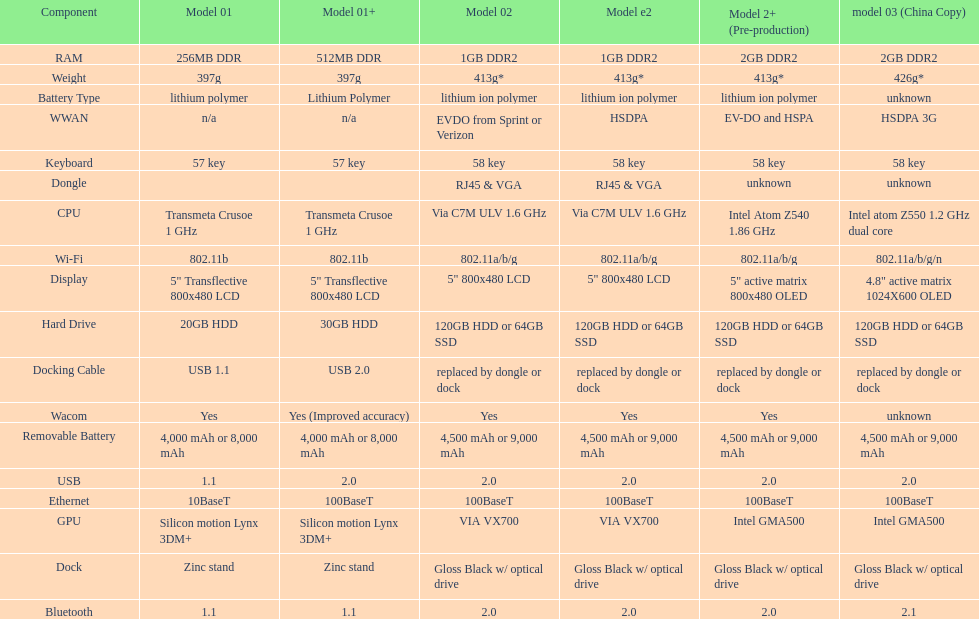What is the average number of models that have usb 2.0? 5. 